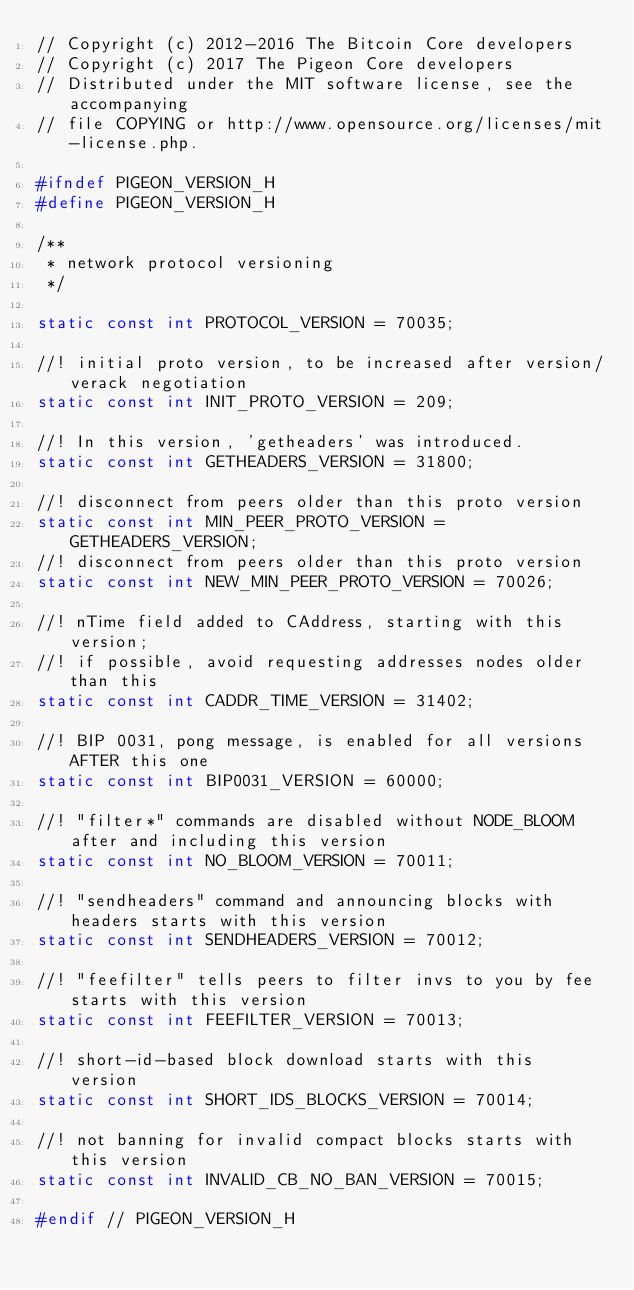Convert code to text. <code><loc_0><loc_0><loc_500><loc_500><_C_>// Copyright (c) 2012-2016 The Bitcoin Core developers
// Copyright (c) 2017 The Pigeon Core developers
// Distributed under the MIT software license, see the accompanying
// file COPYING or http://www.opensource.org/licenses/mit-license.php.

#ifndef PIGEON_VERSION_H
#define PIGEON_VERSION_H

/**
 * network protocol versioning
 */

static const int PROTOCOL_VERSION = 70035;

//! initial proto version, to be increased after version/verack negotiation
static const int INIT_PROTO_VERSION = 209;

//! In this version, 'getheaders' was introduced.
static const int GETHEADERS_VERSION = 31800;

//! disconnect from peers older than this proto version
static const int MIN_PEER_PROTO_VERSION = GETHEADERS_VERSION;
//! disconnect from peers older than this proto version
static const int NEW_MIN_PEER_PROTO_VERSION = 70026;

//! nTime field added to CAddress, starting with this version;
//! if possible, avoid requesting addresses nodes older than this
static const int CADDR_TIME_VERSION = 31402;

//! BIP 0031, pong message, is enabled for all versions AFTER this one
static const int BIP0031_VERSION = 60000;

//! "filter*" commands are disabled without NODE_BLOOM after and including this version
static const int NO_BLOOM_VERSION = 70011;

//! "sendheaders" command and announcing blocks with headers starts with this version
static const int SENDHEADERS_VERSION = 70012;

//! "feefilter" tells peers to filter invs to you by fee starts with this version
static const int FEEFILTER_VERSION = 70013;

//! short-id-based block download starts with this version
static const int SHORT_IDS_BLOCKS_VERSION = 70014;

//! not banning for invalid compact blocks starts with this version
static const int INVALID_CB_NO_BAN_VERSION = 70015;

#endif // PIGEON_VERSION_H
</code> 